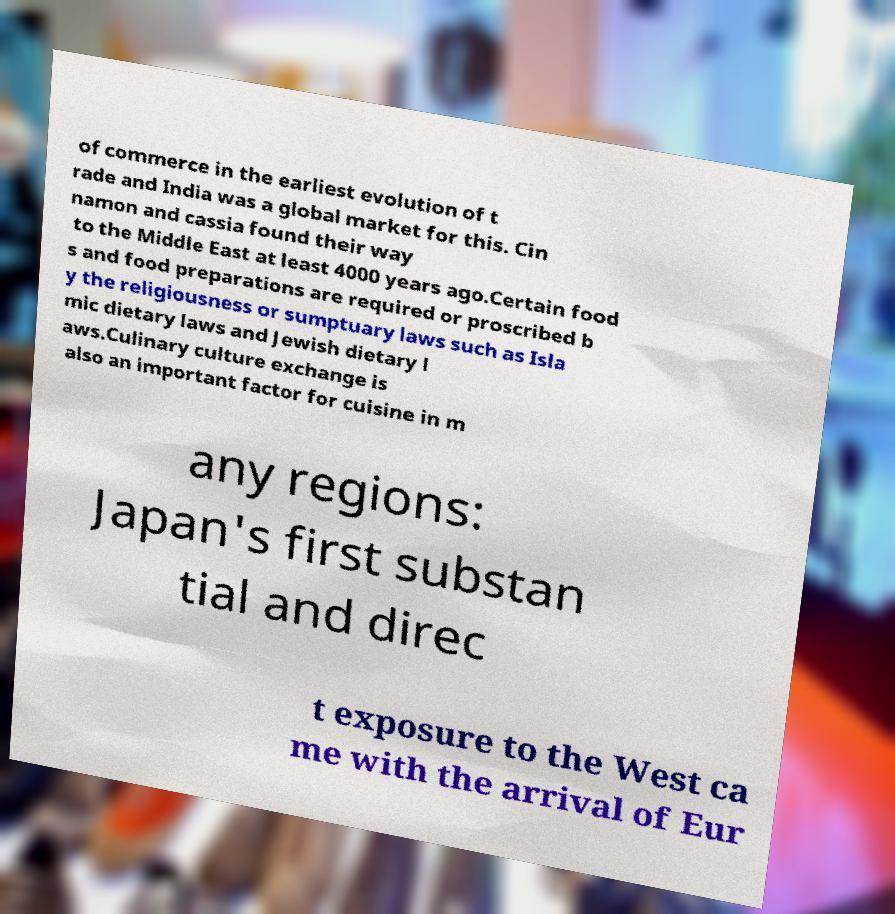Please identify and transcribe the text found in this image. of commerce in the earliest evolution of t rade and India was a global market for this. Cin namon and cassia found their way to the Middle East at least 4000 years ago.Certain food s and food preparations are required or proscribed b y the religiousness or sumptuary laws such as Isla mic dietary laws and Jewish dietary l aws.Culinary culture exchange is also an important factor for cuisine in m any regions: Japan's first substan tial and direc t exposure to the West ca me with the arrival of Eur 